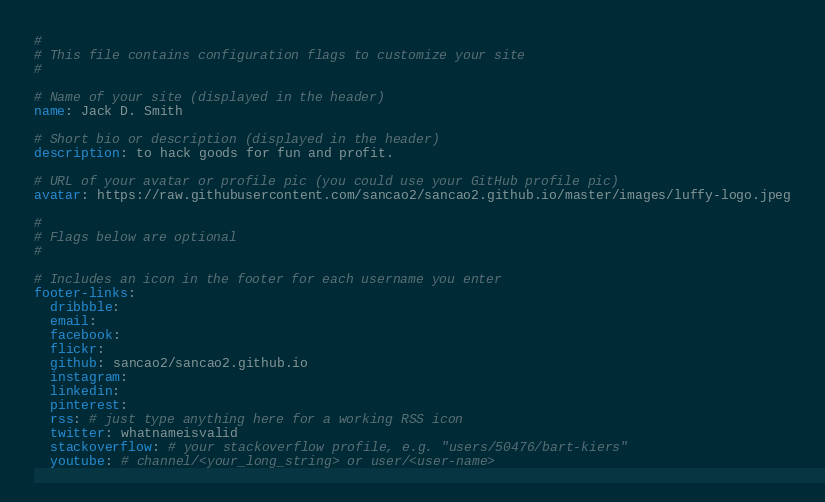Convert code to text. <code><loc_0><loc_0><loc_500><loc_500><_YAML_>#
# This file contains configuration flags to customize your site
#

# Name of your site (displayed in the header)
name: Jack D. Smith

# Short bio or description (displayed in the header)
description: to hack goods for fun and profit.

# URL of your avatar or profile pic (you could use your GitHub profile pic)
avatar: https://raw.githubusercontent.com/sancao2/sancao2.github.io/master/images/luffy-logo.jpeg

#
# Flags below are optional
#

# Includes an icon in the footer for each username you enter
footer-links:
  dribbble:
  email:
  facebook:
  flickr:
  github: sancao2/sancao2.github.io
  instagram:
  linkedin:
  pinterest:
  rss: # just type anything here for a working RSS icon
  twitter: whatnameisvalid
  stackoverflow: # your stackoverflow profile, e.g. "users/50476/bart-kiers"
  youtube: # channel/<your_long_string> or user/<user-name></code> 